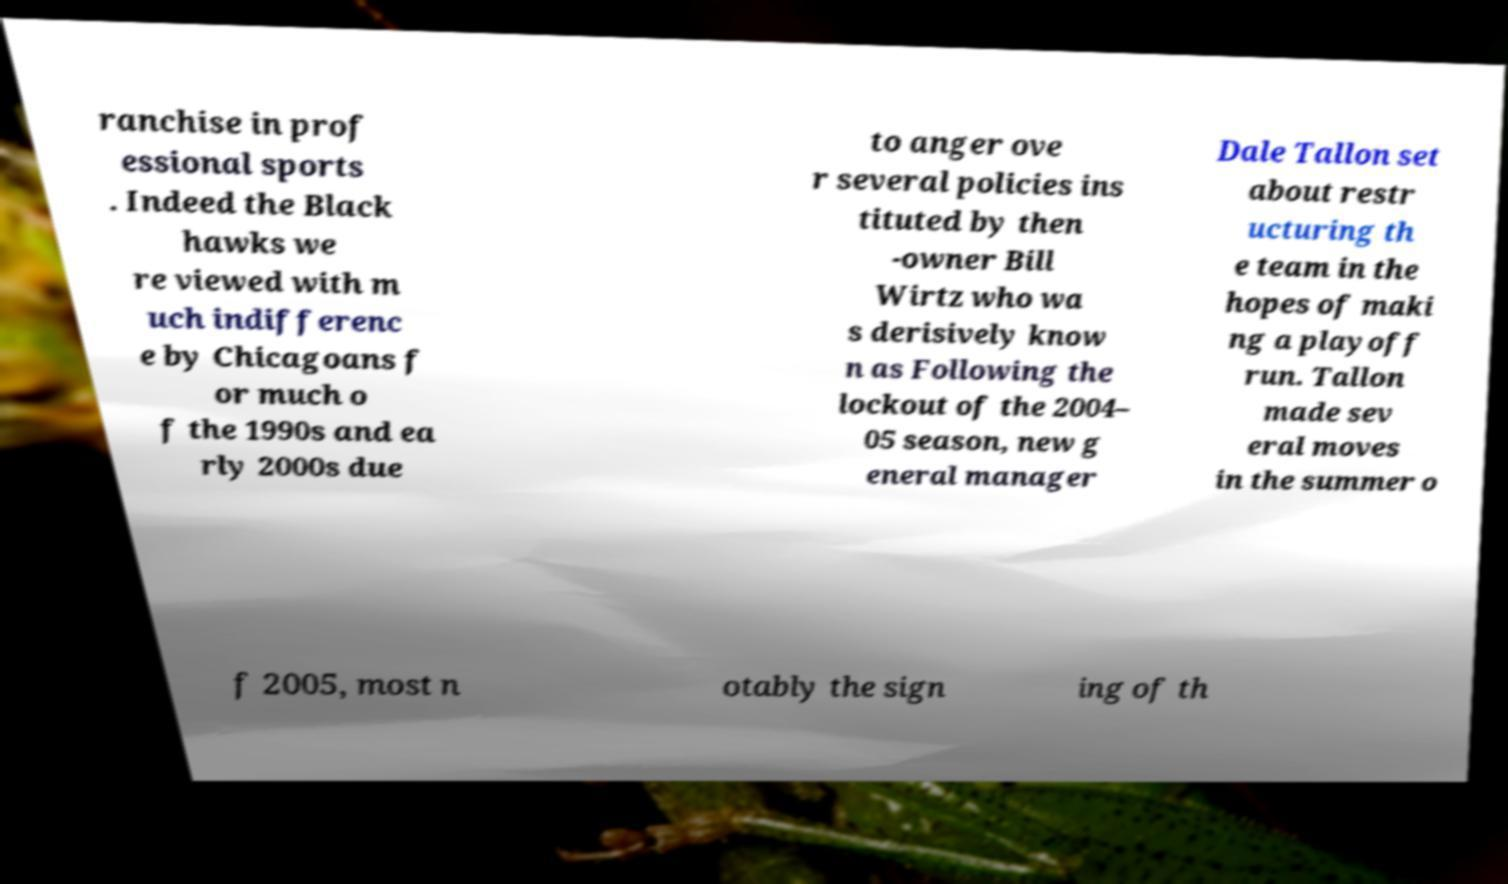Please identify and transcribe the text found in this image. ranchise in prof essional sports . Indeed the Black hawks we re viewed with m uch indifferenc e by Chicagoans f or much o f the 1990s and ea rly 2000s due to anger ove r several policies ins tituted by then -owner Bill Wirtz who wa s derisively know n as Following the lockout of the 2004– 05 season, new g eneral manager Dale Tallon set about restr ucturing th e team in the hopes of maki ng a playoff run. Tallon made sev eral moves in the summer o f 2005, most n otably the sign ing of th 